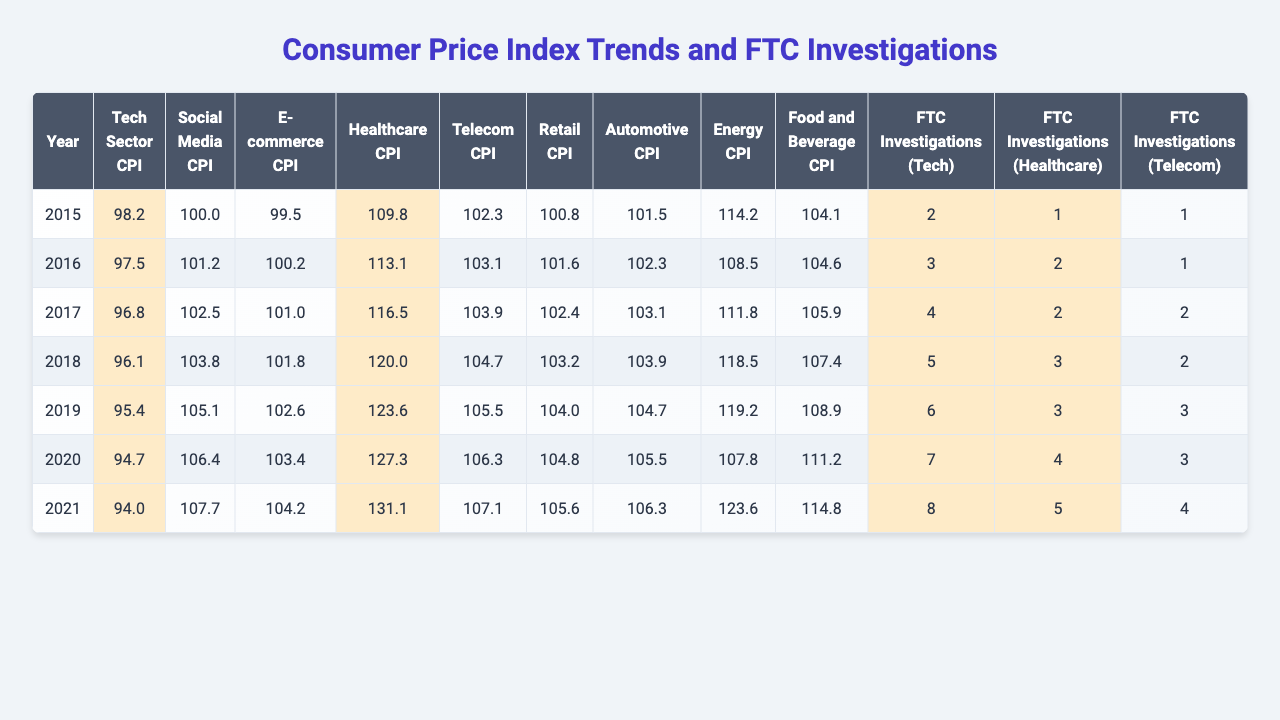What was the Consumer Price Index (CPI) for the Tech sector in 2019? The table indicates that the CPI for the Tech sector in 2019 is 95.4.
Answer: 95.4 What was the CPI for the Social Media sector in the year 2021? Referring to the table, the CPI for the Social Media sector in 2021 is 107.7.
Answer: 107.7 Which sector had the highest CPI in 2018? The table shows that the Healthcare sector had the highest CPI in 2018 at 120.0.
Answer: Healthcare What is the average CPI for the Automotive and E-commerce sectors over the years? The average CPI for Automotive is (101.5 + 102.3 + 103.1 + 103.9 + 104.7 + 105.5 + 106.3) = 104.4, and for E-commerce, it's (99.5 + 100.2 + 101.0 + 101.8 + 102.6 + 103.4 + 104.2) = 102.1. The overall average is (104.4 + 102.1) / 2 = 103.25.
Answer: 103.25 Has the CPI for the Energy sector increased or decreased over the years? The table shows that the CPI for the Energy sector changed from 114.2 in 2015 to 123.6 in 2021, indicating an increase.
Answer: Increased In which year did the Tech sector have the same CPI as the E-commerce sector? Looking at the table, the Tech sector CPI and the E-commerce sector CPI were the same in 2016 at 97.5.
Answer: 2016 What is the total number of FTC investigations for the Telecom sector from 2015 to 2021? By summing the number of investigations from the table: 1 + 1 + 2 + 2 + 3 + 3 + 4 = 16.
Answer: 16 Which sector shows a decreasing trend in CPI from 2015 to 2021, and what is the rate of decline for that sector? Analyzing the Tech sector CPI: it declined from 98.2 in 2015 to 94.0 in 2021, resulting in a decrease of 4.2 over 6 years, or about 0.7 per year.
Answer: Tech sector, 0.7/year What was the gap in CPI between the Healthcare and Retail sectors in 2020? In 2020, the CPI for Healthcare is 127.3 and for Retail is 104.8, so the gap is 127.3 - 104.8 = 22.5.
Answer: 22.5 Does the total number of FTC investigations for Healthcare exceed that for Retail in 2019? In 2019, Healthcare had 3 investigations and Retail had 2, so Healthcare does exceed Retail.
Answer: Yes What trend can you infer from the Consumer Price Index of the Social Media sector from 2015 to 2021? The Social Media sector's CPI increased from 100.0 in 2015 to 107.7 in 2021, showing a consistent upward trend over the years.
Answer: Upward trend 